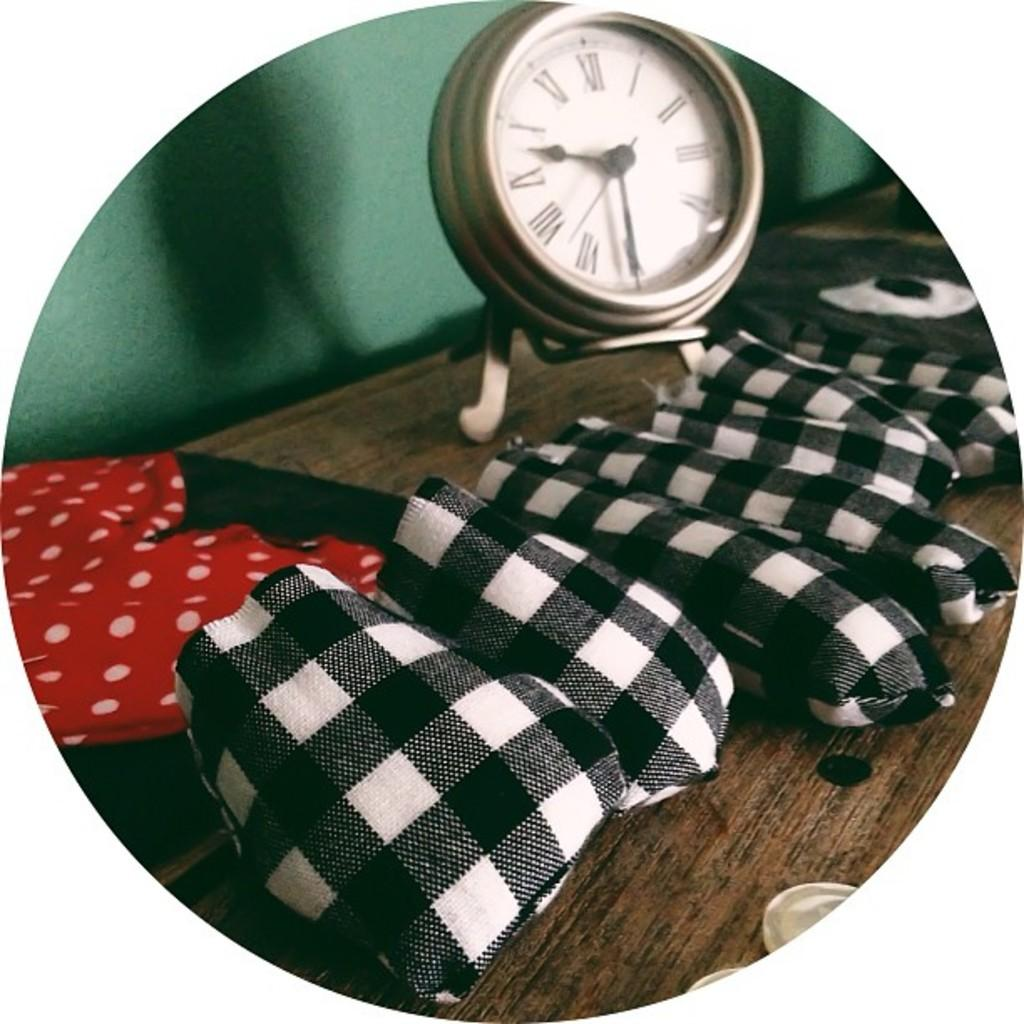<image>
Summarize the visual content of the image. A white faces clock with black arms reads "9:31." 